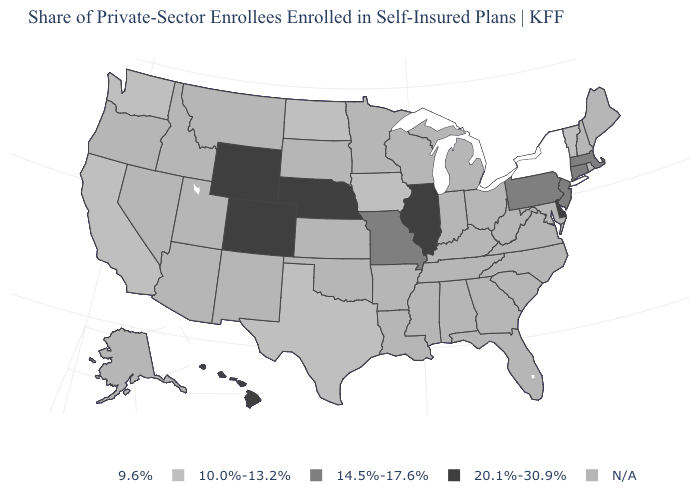Name the states that have a value in the range 9.6%?
Quick response, please. New York. Name the states that have a value in the range 14.5%-17.6%?
Be succinct. Connecticut, Massachusetts, Missouri, New Jersey, Pennsylvania. How many symbols are there in the legend?
Answer briefly. 5. Does the map have missing data?
Write a very short answer. Yes. Among the states that border Minnesota , which have the lowest value?
Answer briefly. Iowa, North Dakota. What is the value of Wyoming?
Write a very short answer. 20.1%-30.9%. What is the value of Arkansas?
Short answer required. N/A. Does Texas have the highest value in the South?
Answer briefly. No. What is the value of New Jersey?
Concise answer only. 14.5%-17.6%. Among the states that border Tennessee , which have the highest value?
Give a very brief answer. Missouri. Does Iowa have the highest value in the USA?
Short answer required. No. Does Illinois have the highest value in the USA?
Short answer required. Yes. Name the states that have a value in the range 10.0%-13.2%?
Quick response, please. California, Iowa, North Dakota, Texas, Vermont, Washington. 